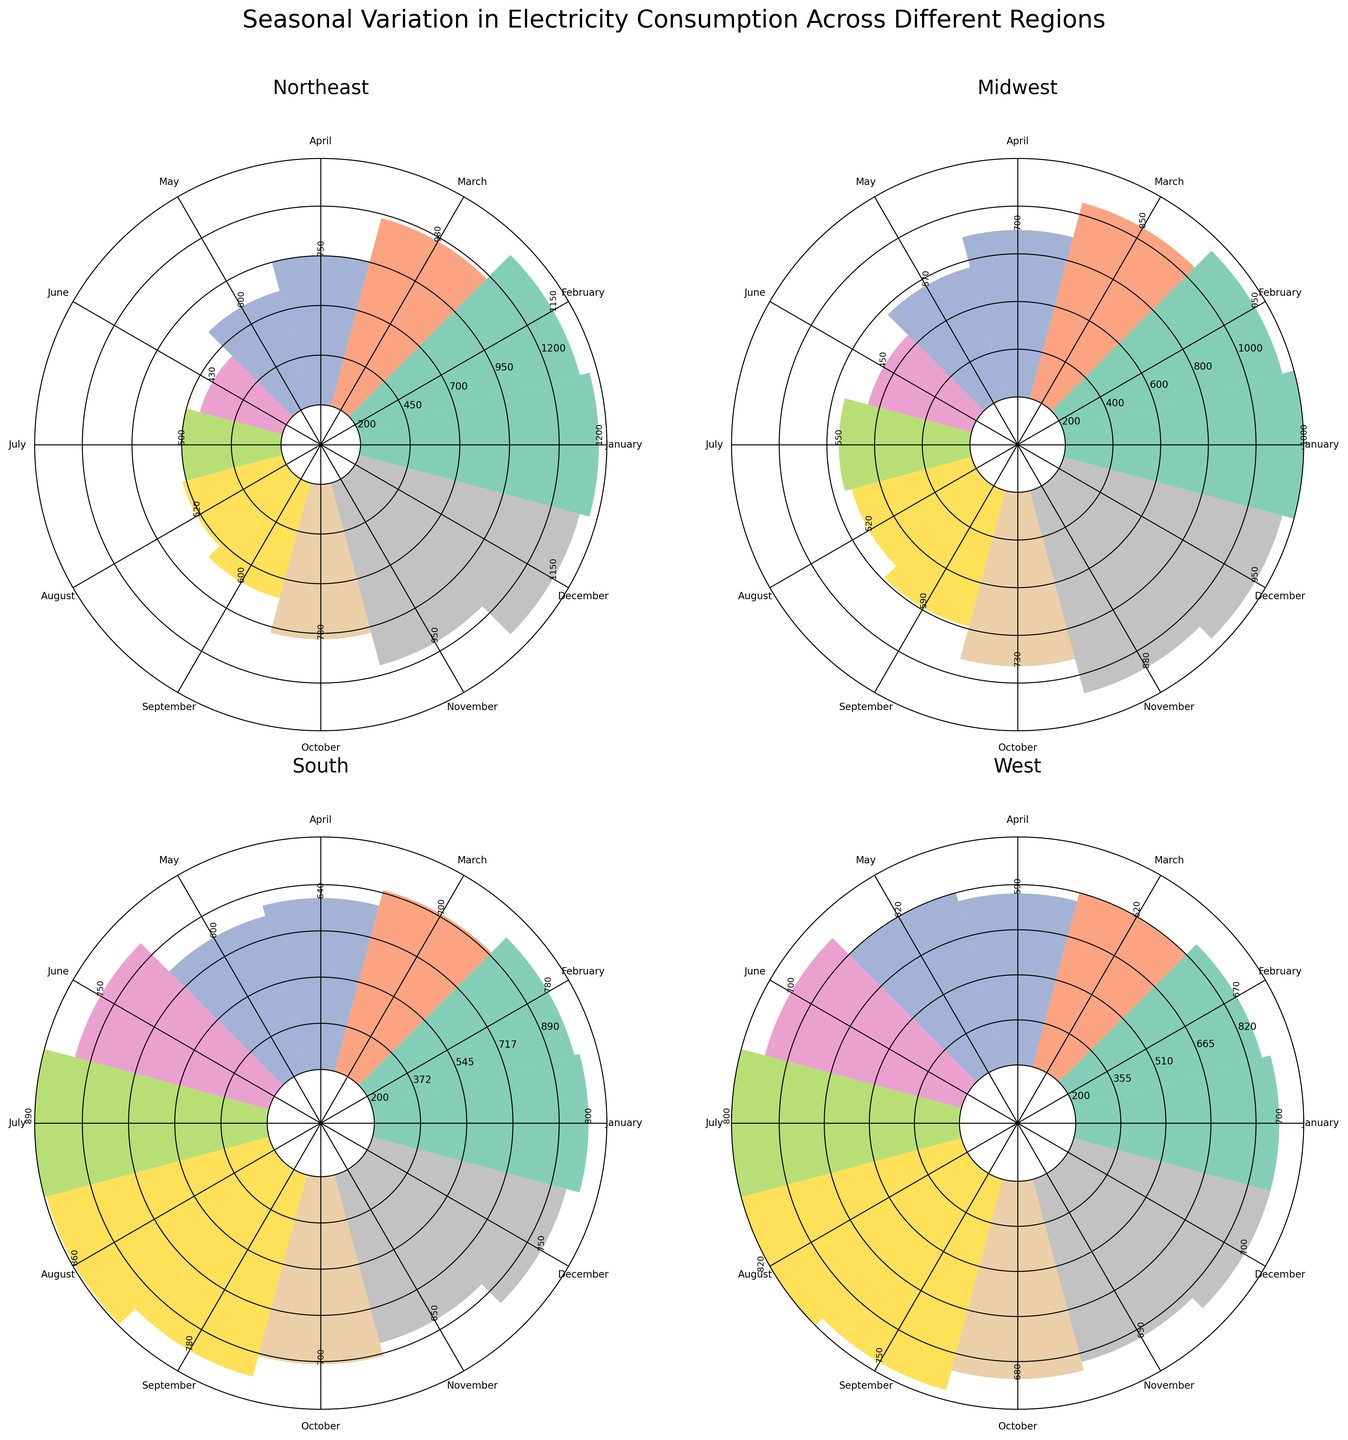What's the highest electricity consumption in the Northeast region? To find this, look for the bar in the Northeast subplot that extends out the furthest. The month of January and December have the highest electricity consumption in the Northeast region, both peeking at 1150 MWh.
Answer: 1150 MWh Which region has the least variation in electricity consumption throughout the year? To determine this, visually inspect which subplot has bars of relatively similar heights. The western region has bars that vary less in height compared to other regions, indicating less variation in their electricity consumption.
Answer: West In which month does the South region consume the most electricity? Look at the subplot for the South region and identify the tallest bar. The tallest bar in the South subplot is in July with an electricity consumption of 890 MWh.
Answer: July How does the electricity consumption in the Midwest region in July compare to June? Check the heights of the bars for July and June in the Midwest subplot. In July, the consumption is 550 MWh, while in June, it is 450 MWh. Thus, July's consumption is higher by 100 MWh.
Answer: 100 MWh more What is the overall trend of electricity consumption in the Northeast region from January to December? Observe the heights of the bars in the Northeast subplot starting from January and ending in December. The trend shows a high consumption in the winter months (January, February, November, and December), decreases in the spring and summer months, and gradually increases again in the fall.
Answer: High in winter, low in summer Which region shows the highest electricity consumption in the summer months? Consider the months of June, July, and August across all subplots and look for the tallest bars. The South region shows the highest consumption in July with 890 MWh.
Answer: South Is there any region where the electricity consumption is higher in winter than in summer? Compare the heights of the winter bars (December - February) with the summer bars (June - August) for each region. The Northeast and Midwest both show higher consumption in the winter months compared to the summer months.
Answer: Northeast and Midwest Which month has the lowest electricity consumption in the West region? Identify the shortest bar in the West subplot. March has the lowest consumption in the West with 620 MWh.
Answer: March What's the average electricity consumption in the South region during the spring months (March, April, May)? Check the heights of the bars for March, April, and May in the South subplot. The consumption for these months are 700 MWh, 640 MWh, and 600 MWh respectively. The average is (700 + 640 + 600) / 3 = 646.67 MWh.
Answer: 646.67 MWh 